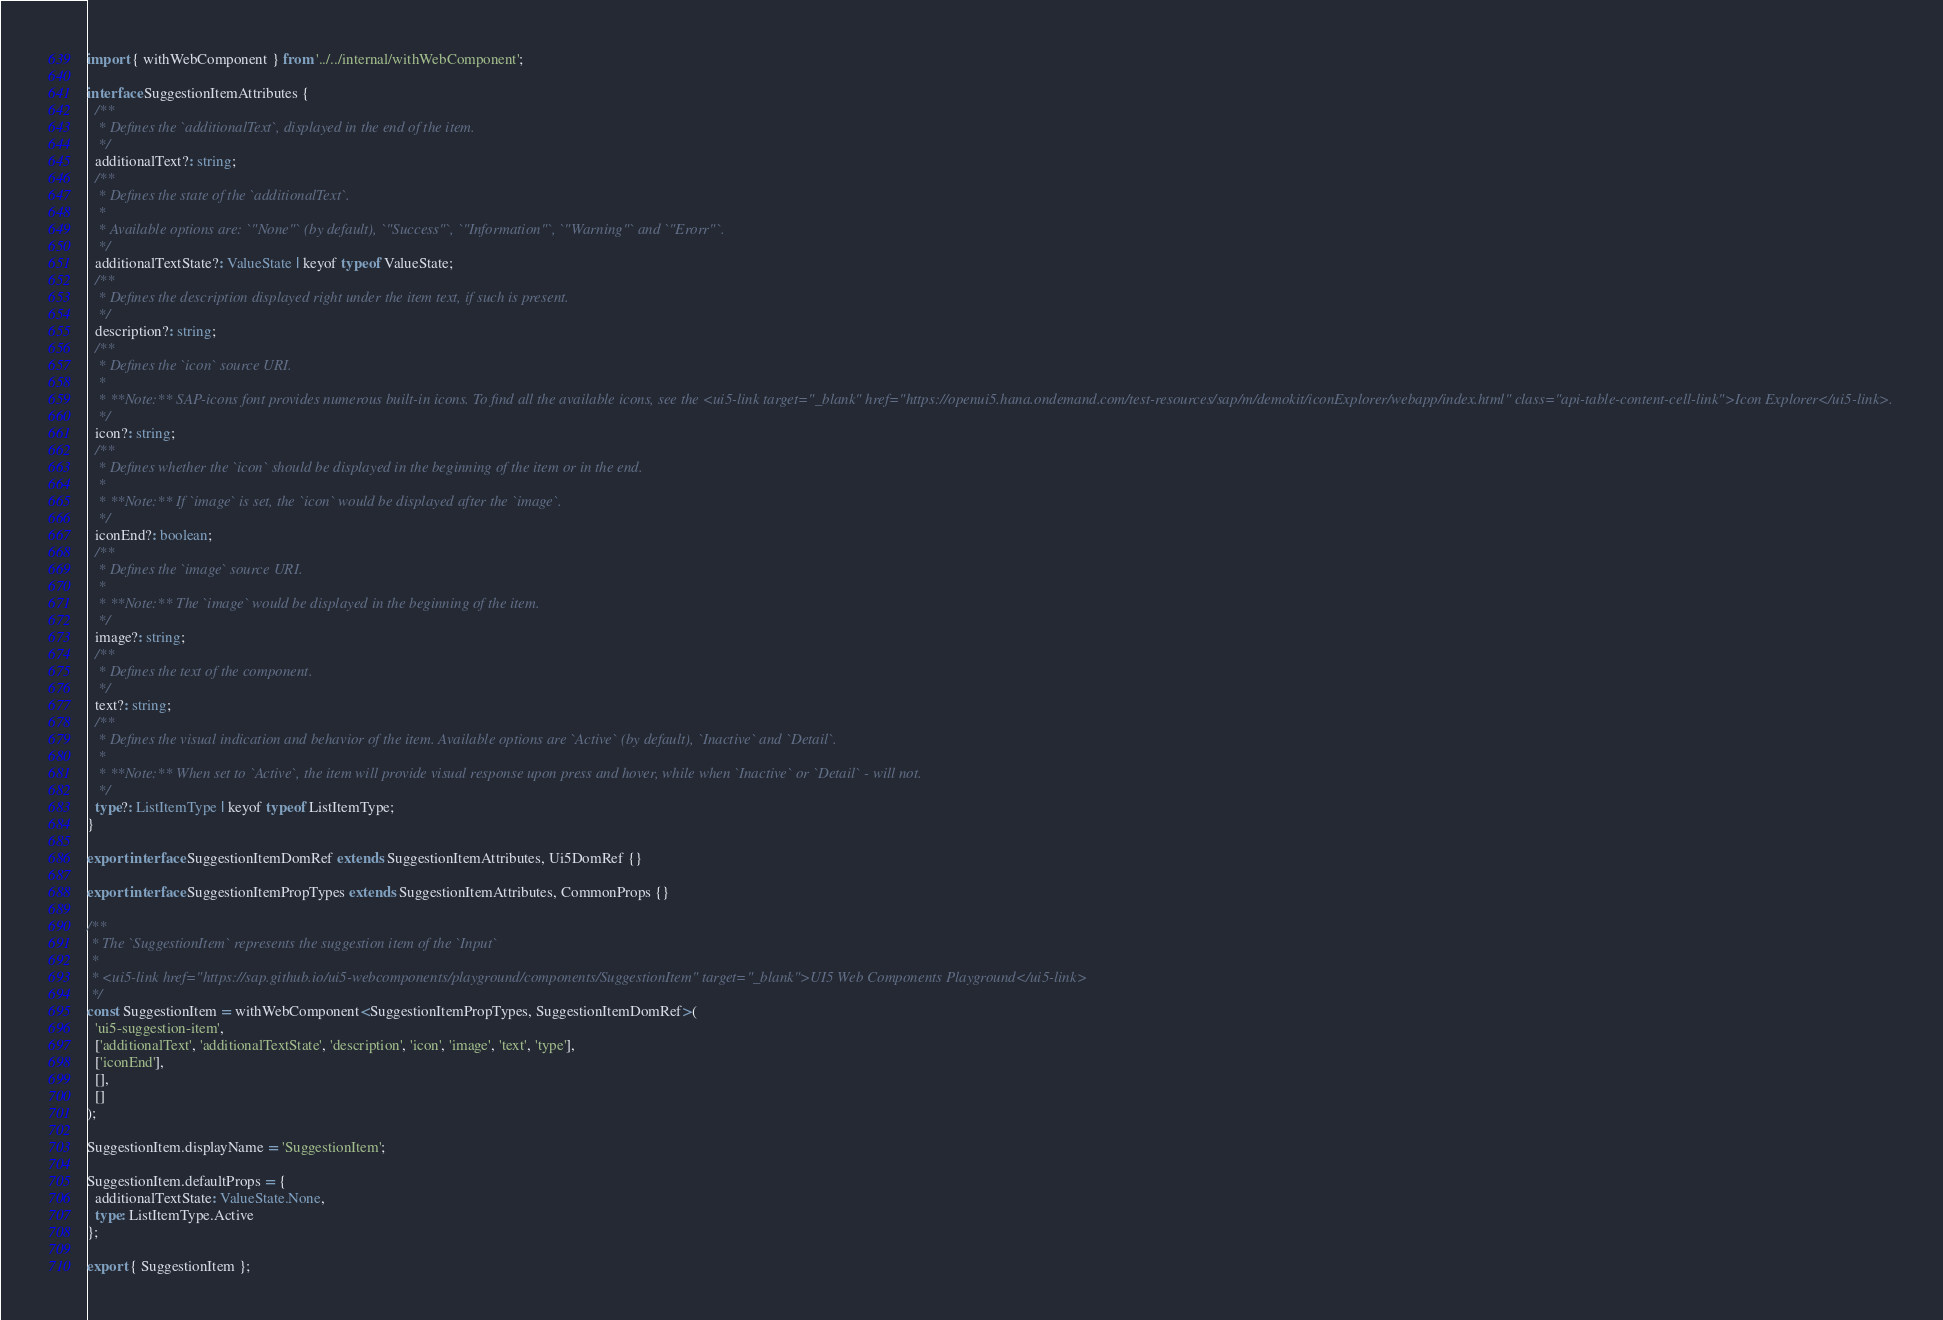<code> <loc_0><loc_0><loc_500><loc_500><_TypeScript_>import { withWebComponent } from '../../internal/withWebComponent';

interface SuggestionItemAttributes {
  /**
   * Defines the `additionalText`, displayed in the end of the item.
   */
  additionalText?: string;
  /**
   * Defines the state of the `additionalText`.
   *
   * Available options are: `"None"` (by default), `"Success"`, `"Information"`, `"Warning"` and `"Erorr"`.
   */
  additionalTextState?: ValueState | keyof typeof ValueState;
  /**
   * Defines the description displayed right under the item text, if such is present.
   */
  description?: string;
  /**
   * Defines the `icon` source URI.
   *
   * **Note:** SAP-icons font provides numerous built-in icons. To find all the available icons, see the <ui5-link target="_blank" href="https://openui5.hana.ondemand.com/test-resources/sap/m/demokit/iconExplorer/webapp/index.html" class="api-table-content-cell-link">Icon Explorer</ui5-link>.
   */
  icon?: string;
  /**
   * Defines whether the `icon` should be displayed in the beginning of the item or in the end.
   *
   * **Note:** If `image` is set, the `icon` would be displayed after the `image`.
   */
  iconEnd?: boolean;
  /**
   * Defines the `image` source URI.
   *
   * **Note:** The `image` would be displayed in the beginning of the item.
   */
  image?: string;
  /**
   * Defines the text of the component.
   */
  text?: string;
  /**
   * Defines the visual indication and behavior of the item. Available options are `Active` (by default), `Inactive` and `Detail`.
   *
   * **Note:** When set to `Active`, the item will provide visual response upon press and hover, while when `Inactive` or `Detail` - will not.
   */
  type?: ListItemType | keyof typeof ListItemType;
}

export interface SuggestionItemDomRef extends SuggestionItemAttributes, Ui5DomRef {}

export interface SuggestionItemPropTypes extends SuggestionItemAttributes, CommonProps {}

/**
 * The `SuggestionItem` represents the suggestion item of the `Input`
 *
 * <ui5-link href="https://sap.github.io/ui5-webcomponents/playground/components/SuggestionItem" target="_blank">UI5 Web Components Playground</ui5-link>
 */
const SuggestionItem = withWebComponent<SuggestionItemPropTypes, SuggestionItemDomRef>(
  'ui5-suggestion-item',
  ['additionalText', 'additionalTextState', 'description', 'icon', 'image', 'text', 'type'],
  ['iconEnd'],
  [],
  []
);

SuggestionItem.displayName = 'SuggestionItem';

SuggestionItem.defaultProps = {
  additionalTextState: ValueState.None,
  type: ListItemType.Active
};

export { SuggestionItem };
</code> 